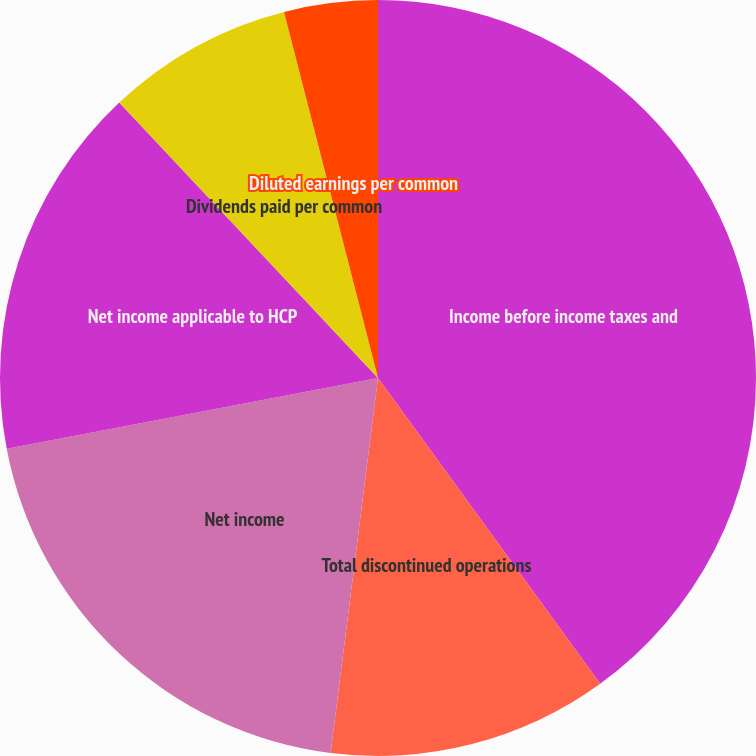Convert chart to OTSL. <chart><loc_0><loc_0><loc_500><loc_500><pie_chart><fcel>Income before income taxes and<fcel>Total discontinued operations<fcel>Net income<fcel>Net income applicable to HCP<fcel>Dividends paid per common<fcel>Basic earnings per common<fcel>Diluted earnings per common<nl><fcel>40.0%<fcel>12.0%<fcel>20.0%<fcel>16.0%<fcel>8.0%<fcel>0.0%<fcel>4.0%<nl></chart> 